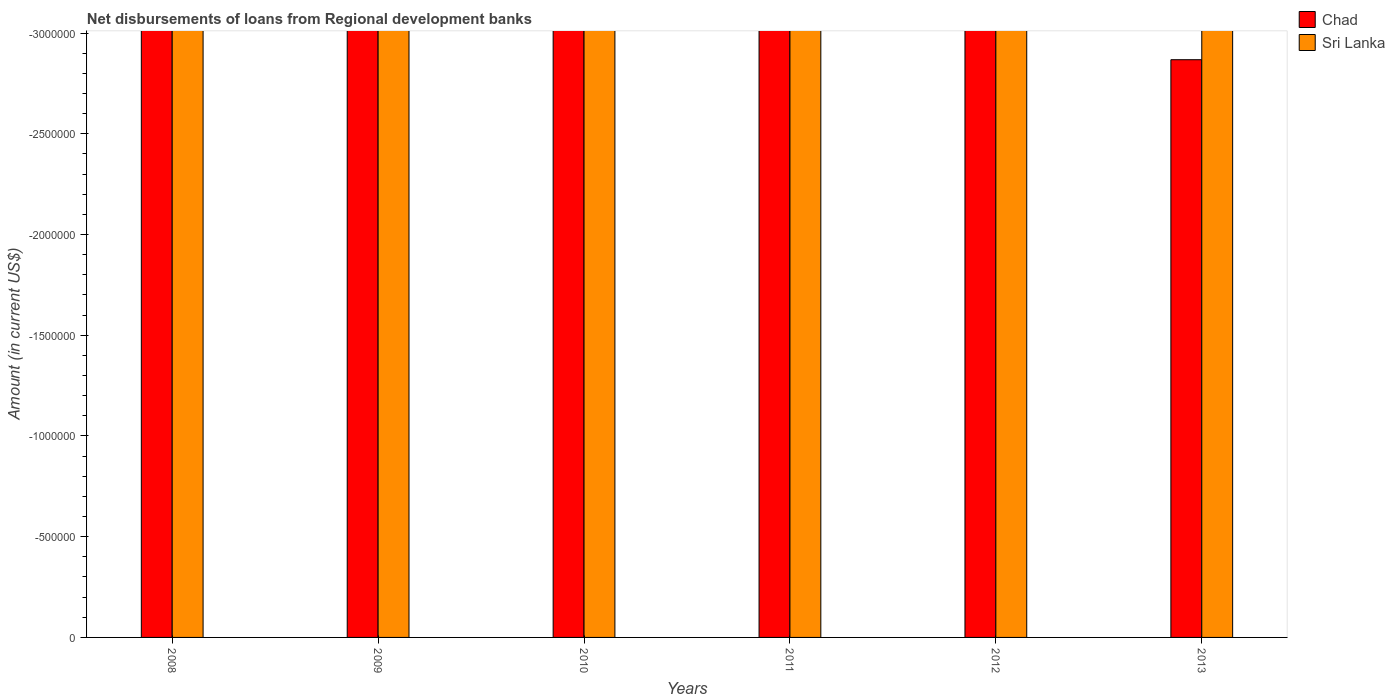Are the number of bars per tick equal to the number of legend labels?
Provide a succinct answer. No. Are the number of bars on each tick of the X-axis equal?
Your answer should be very brief. Yes. How many bars are there on the 5th tick from the right?
Provide a short and direct response. 0. What is the label of the 5th group of bars from the left?
Make the answer very short. 2012. In how many cases, is the number of bars for a given year not equal to the number of legend labels?
Offer a terse response. 6. Across all years, what is the minimum amount of disbursements of loans from regional development banks in Sri Lanka?
Your answer should be very brief. 0. What is the average amount of disbursements of loans from regional development banks in Sri Lanka per year?
Keep it short and to the point. 0. In how many years, is the amount of disbursements of loans from regional development banks in Sri Lanka greater than -2300000 US$?
Keep it short and to the point. 0. Does the graph contain any zero values?
Your response must be concise. Yes. Does the graph contain grids?
Keep it short and to the point. No. Where does the legend appear in the graph?
Provide a succinct answer. Top right. How are the legend labels stacked?
Provide a short and direct response. Vertical. What is the title of the graph?
Provide a succinct answer. Net disbursements of loans from Regional development banks. Does "Macao" appear as one of the legend labels in the graph?
Offer a very short reply. No. What is the label or title of the X-axis?
Ensure brevity in your answer.  Years. What is the label or title of the Y-axis?
Offer a very short reply. Amount (in current US$). What is the Amount (in current US$) in Sri Lanka in 2008?
Offer a terse response. 0. What is the Amount (in current US$) of Chad in 2010?
Offer a terse response. 0. What is the Amount (in current US$) of Chad in 2011?
Offer a very short reply. 0. What is the Amount (in current US$) of Sri Lanka in 2011?
Your response must be concise. 0. What is the average Amount (in current US$) of Chad per year?
Make the answer very short. 0. What is the average Amount (in current US$) in Sri Lanka per year?
Your response must be concise. 0. 